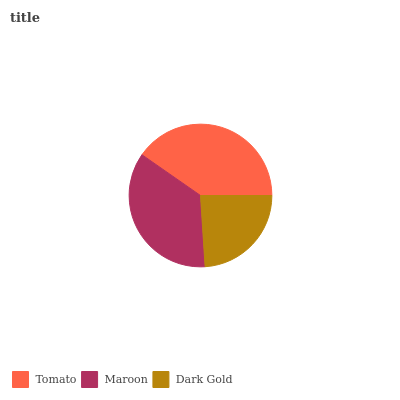Is Dark Gold the minimum?
Answer yes or no. Yes. Is Tomato the maximum?
Answer yes or no. Yes. Is Maroon the minimum?
Answer yes or no. No. Is Maroon the maximum?
Answer yes or no. No. Is Tomato greater than Maroon?
Answer yes or no. Yes. Is Maroon less than Tomato?
Answer yes or no. Yes. Is Maroon greater than Tomato?
Answer yes or no. No. Is Tomato less than Maroon?
Answer yes or no. No. Is Maroon the high median?
Answer yes or no. Yes. Is Maroon the low median?
Answer yes or no. Yes. Is Tomato the high median?
Answer yes or no. No. Is Tomato the low median?
Answer yes or no. No. 